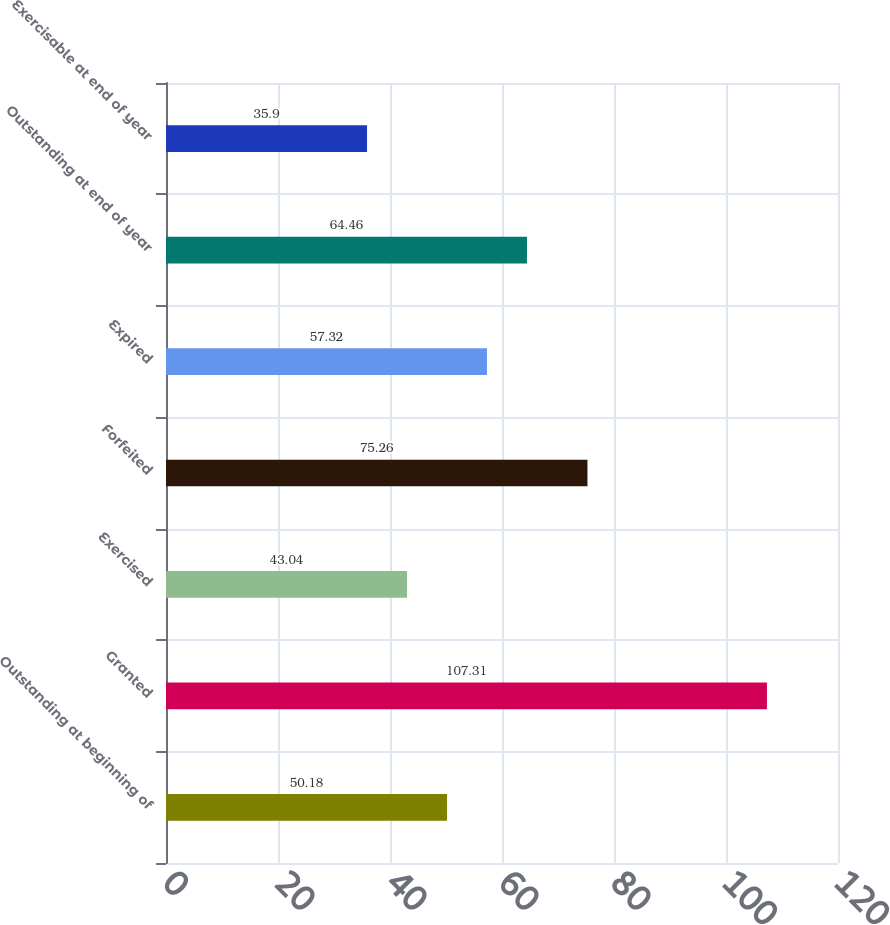Convert chart to OTSL. <chart><loc_0><loc_0><loc_500><loc_500><bar_chart><fcel>Outstanding at beginning of<fcel>Granted<fcel>Exercised<fcel>Forfeited<fcel>Expired<fcel>Outstanding at end of year<fcel>Exercisable at end of year<nl><fcel>50.18<fcel>107.31<fcel>43.04<fcel>75.26<fcel>57.32<fcel>64.46<fcel>35.9<nl></chart> 